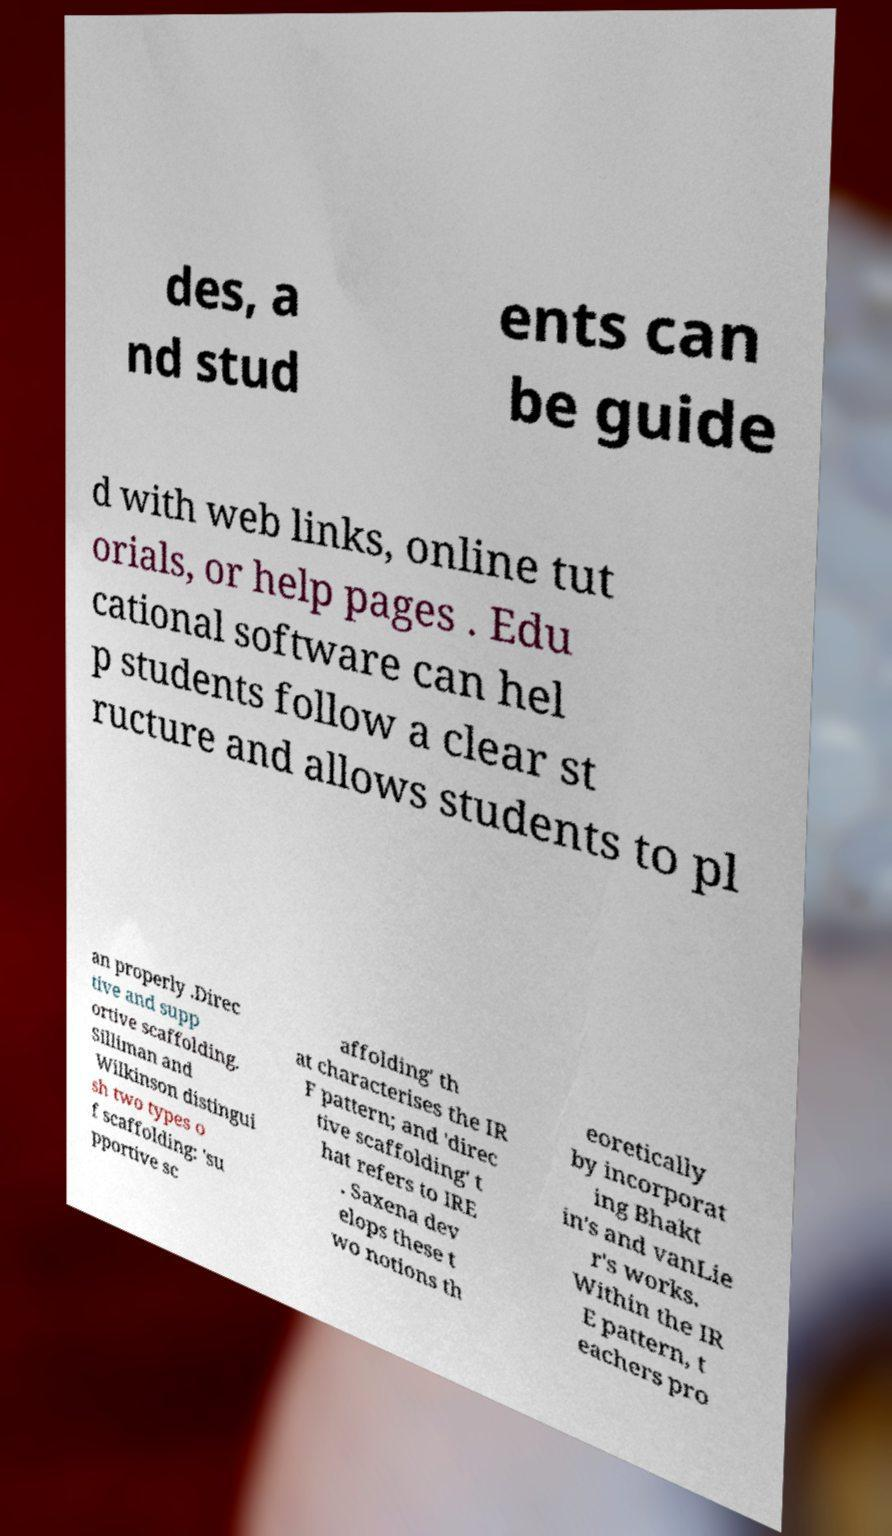There's text embedded in this image that I need extracted. Can you transcribe it verbatim? des, a nd stud ents can be guide d with web links, online tut orials, or help pages . Edu cational software can hel p students follow a clear st ructure and allows students to pl an properly .Direc tive and supp ortive scaffolding. Silliman and Wilkinson distingui sh two types o f scaffolding: 'su pportive sc affolding' th at characterises the IR F pattern; and 'direc tive scaffolding' t hat refers to IRE . Saxena dev elops these t wo notions th eoretically by incorporat ing Bhakt in's and vanLie r's works. Within the IR E pattern, t eachers pro 